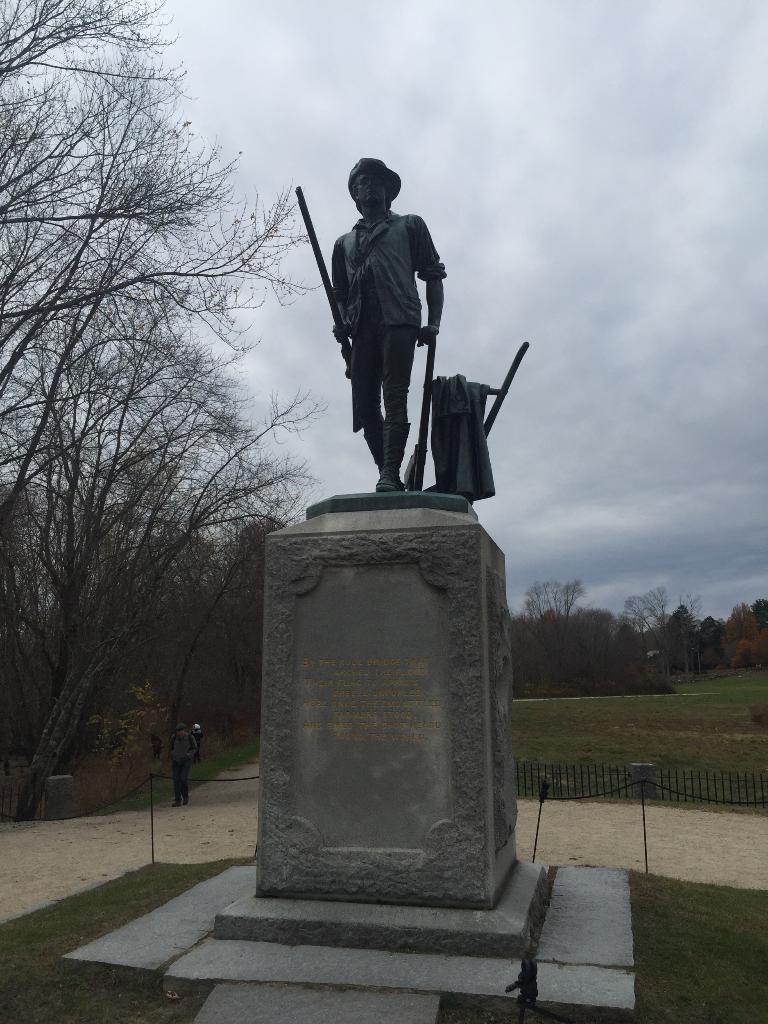In one or two sentences, can you explain what this image depicts? In the center of the image we can see a statue. In the background of the image we can see the trees, grass, fence, road, barricades. On the left side of the image we can see a man is standing. At the top of the image we can see the clouds in the sky. 